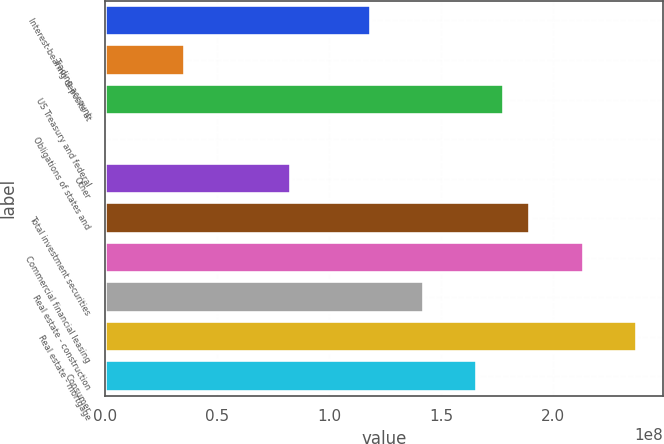Convert chart to OTSL. <chart><loc_0><loc_0><loc_500><loc_500><bar_chart><fcel>Interest-bearing deposits at<fcel>Trading account<fcel>US Treasury and federal<fcel>Obligations of states and<fcel>Other<fcel>Total investment securities<fcel>Commercial financial leasing<fcel>Real estate - construction<fcel>Real estate - mortgage<fcel>Consumer<nl><fcel>1.18593e+08<fcel>3.55971e+07<fcel>1.77877e+08<fcel>27151<fcel>8.30236e+07<fcel>1.89733e+08<fcel>2.13447e+08<fcel>1.42307e+08<fcel>2.3716e+08<fcel>1.6602e+08<nl></chart> 